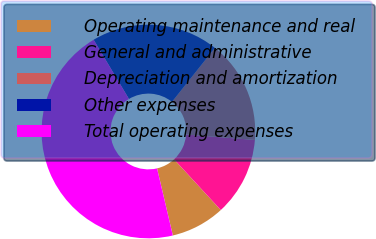<chart> <loc_0><loc_0><loc_500><loc_500><pie_chart><fcel>Operating maintenance and real<fcel>General and administrative<fcel>Depreciation and amortization<fcel>Other expenses<fcel>Total operating expenses<nl><fcel>8.18%<fcel>11.88%<fcel>15.57%<fcel>19.26%<fcel>45.11%<nl></chart> 